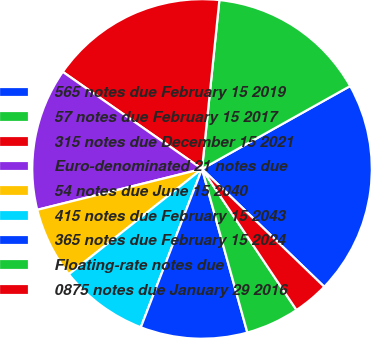Convert chart to OTSL. <chart><loc_0><loc_0><loc_500><loc_500><pie_chart><fcel>565 notes due February 15 2019<fcel>57 notes due February 15 2017<fcel>315 notes due December 15 2021<fcel>Euro-denominated 21 notes due<fcel>54 notes due June 15 2040<fcel>415 notes due February 15 2043<fcel>365 notes due February 15 2024<fcel>Floating-rate notes due<fcel>0875 notes due January 29 2016<nl><fcel>20.33%<fcel>15.25%<fcel>16.94%<fcel>13.56%<fcel>6.78%<fcel>8.48%<fcel>10.17%<fcel>5.09%<fcel>3.4%<nl></chart> 